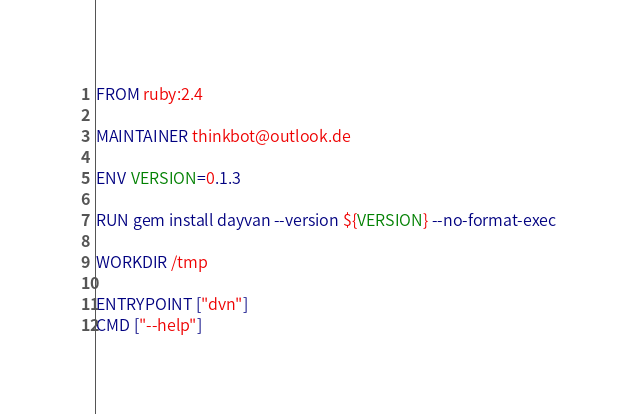<code> <loc_0><loc_0><loc_500><loc_500><_Dockerfile_>FROM ruby:2.4

MAINTAINER thinkbot@outlook.de

ENV VERSION=0.1.3

RUN gem install dayvan --version ${VERSION} --no-format-exec

WORKDIR /tmp

ENTRYPOINT ["dvn"]
CMD ["--help"]
</code> 